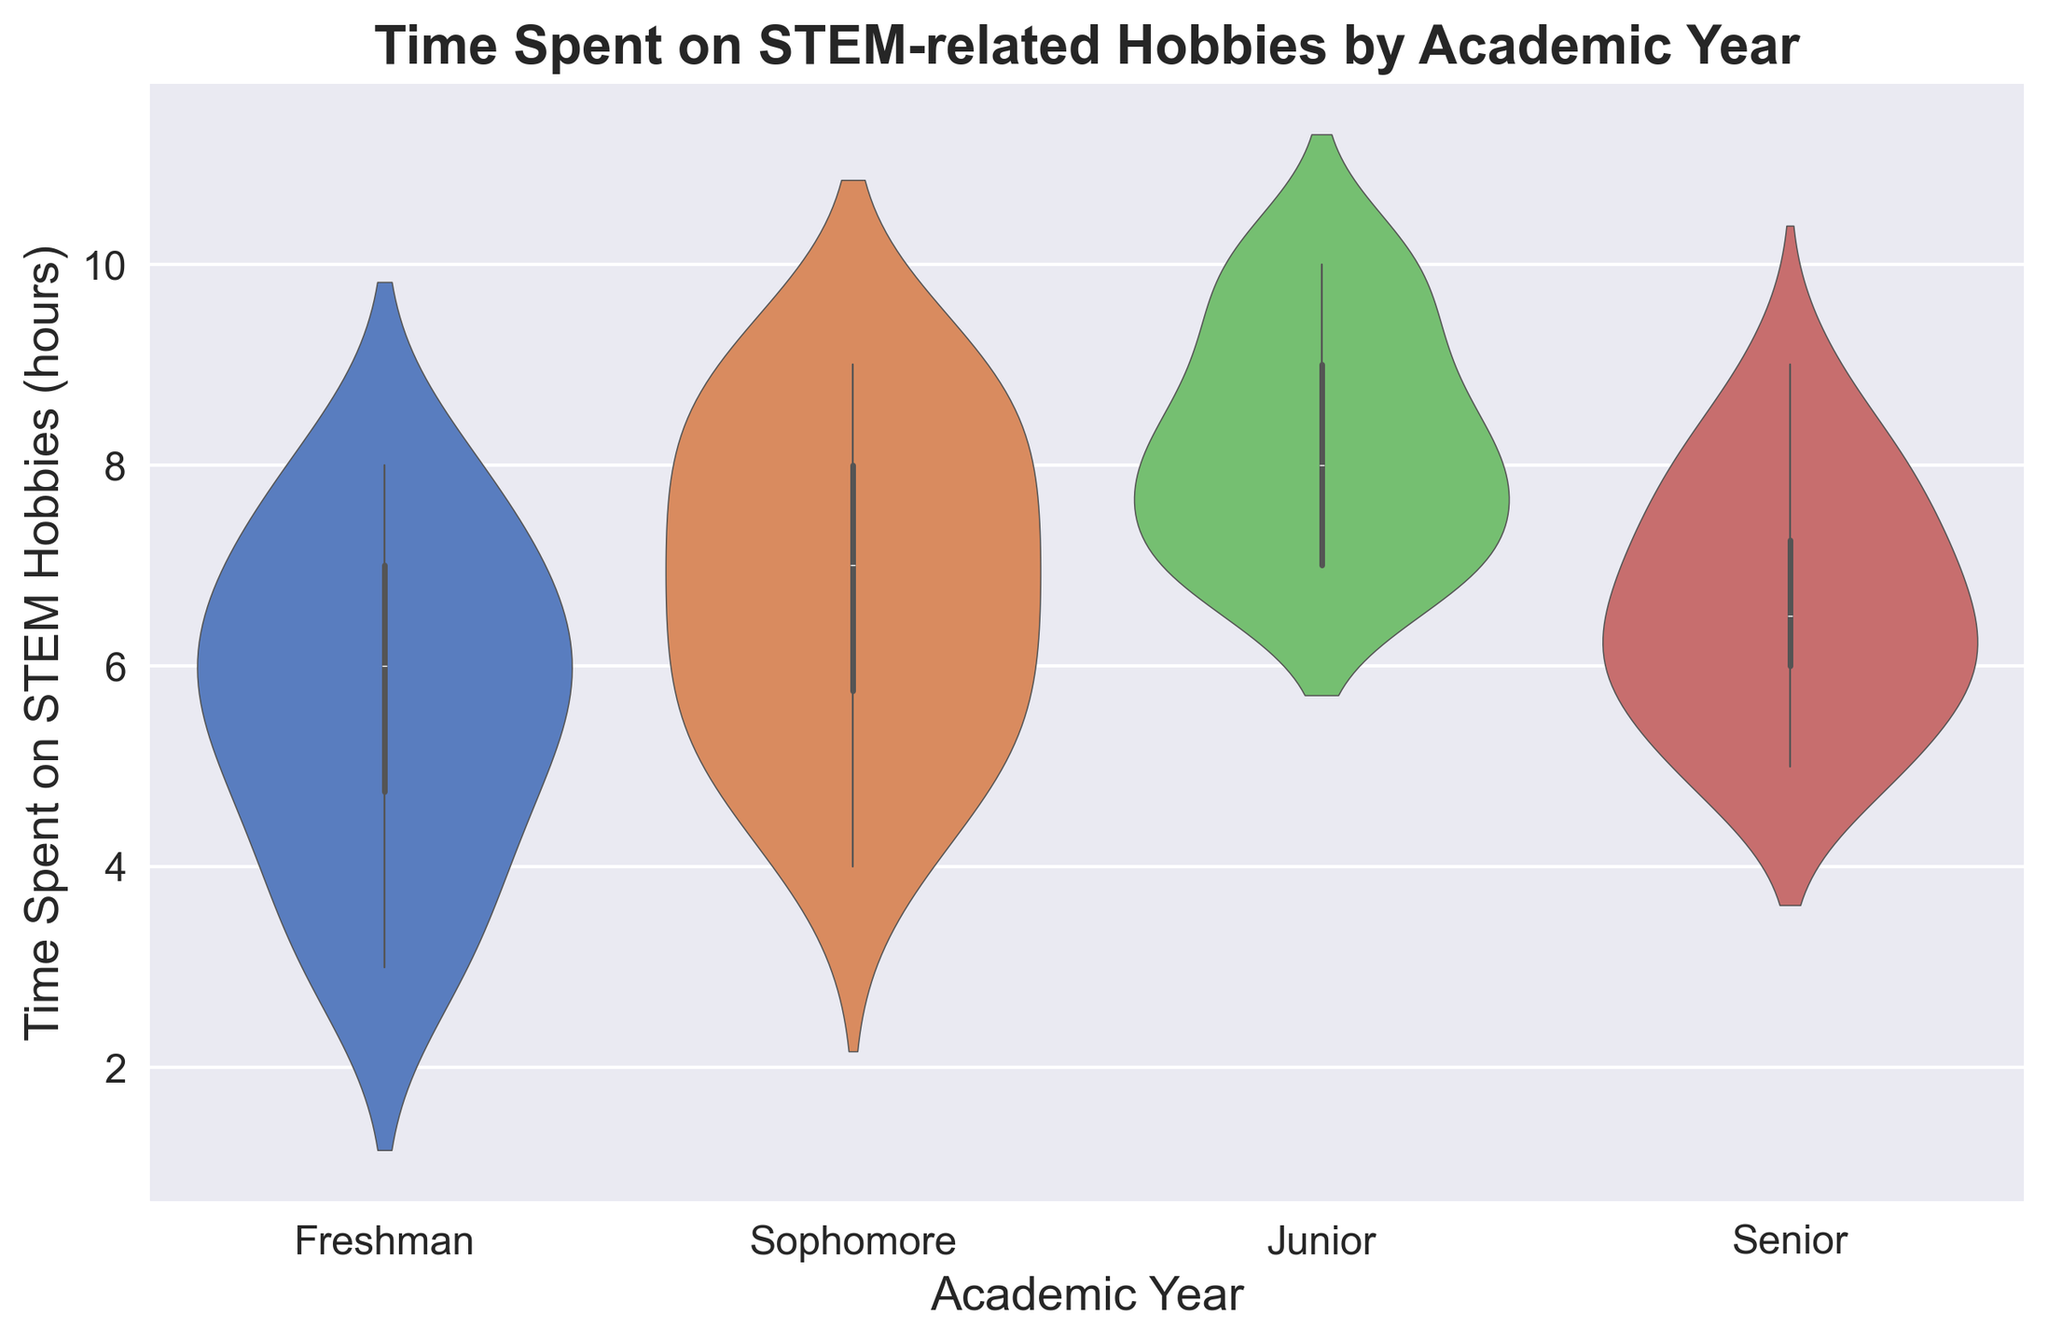Which academic year has the highest median time spent on STEM hobbies? To determine the academic year with the highest median time, locate the central mark (median) of the violin plot for each academic year. The Junior year has the top central mark compared to the others.
Answer: Junior Which academic year shows the widest variation in time spent on STEM hobbies? Identify the academic year with the broadest spread from the bottom to the top of the violin plot. The Sophomore year exhibits the broadest range of time spent.
Answer: Sophomore How does the variability in time spent on STEM hobbies between Freshmen and Seniors compare? Compare the spread or width of the violin plots for Freshmen and Seniors. Freshmen show more variability with a wider spread compared to Seniors, who have a tighter plot.
Answer: Freshmen have more variability What is the approximate interquartile range (IQR) of time spent for Juniors? The interquartile range is the middle 50% of data. Estimate from the bottom and top of the wider central part of the Junior's violin plot. The IQR appears to be from about 7 to 9 hours.
Answer: Approximately 2 hours Which academic year has the least time (minimum) spent on STEM hobbies? Observe the lowest point of each violin plot, which represents the minimum value for each academic year. Freshmen have the lowest minimum value.
Answer: Freshmen Between Sophomores and Seniors, which group has a higher lower quartile for time spent on STEM hobbies? Observe the lower part of the bulging area of each violin plot, which represents the lower quartile. Sophomores have a higher lower quartile compared to Seniors.
Answer: Sophomores What is the median time spent on STEM hobbies by Freshmen? Identify the central mark of the Freshmen's violin plot. The median appears to be around 6 hours.
Answer: 6 hours By how much is the median time spent on STEM hobbies higher in Juniors compared to Freshmen? Compare the central marks of the Freshmen and Junior's violin plots. Juniors have a median around 8 hours, whereas Freshmen have a median around 6 hours. So, the difference is about 2 hours.
Answer: 2 hours Which academic year shows the smallest range of time spent on STEM hobbies? Identify the academic year with the smallest spread from bottom to top of the violin plot. Seniors exhibit the smallest range of time spent.
Answer: Seniors 